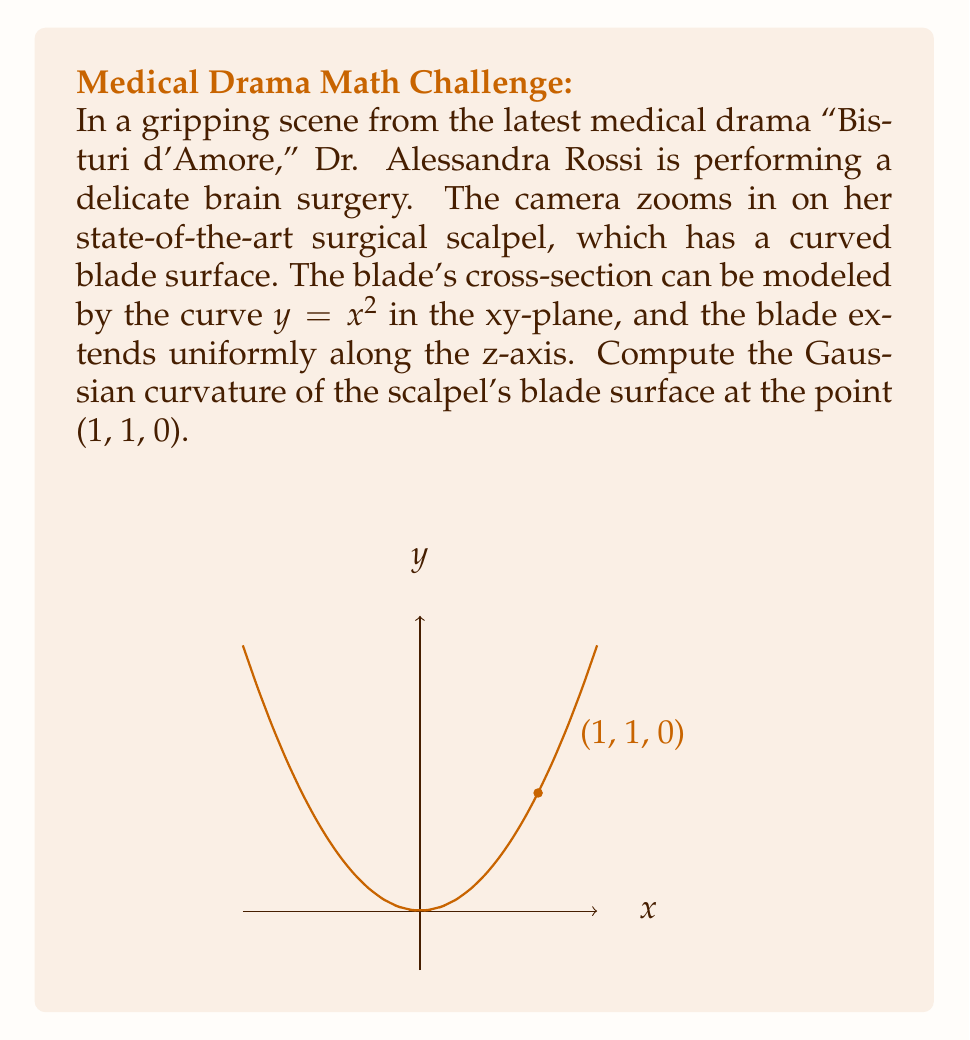Can you answer this question? To compute the Gaussian curvature of the scalpel's blade surface, we'll follow these steps:

1) The surface is a cylinder with the directrix $y = x^2$ and generatrix parallel to the z-axis. This is a ruled surface.

2) For a ruled surface where one of the principal directions is along the rulings (z-axis in this case), the Gaussian curvature K is given by:

   $$K = -\frac{(k_n')^2}{(1 + k_n^2)^2}$$

   where $k_n$ is the normal curvature of the directrix curve.

3) To find $k_n$, we need to calculate the curvature of the curve $y = x^2$ at x = 1.

4) The curvature of a plane curve $y = f(x)$ is given by:

   $$k = \frac{|f''(x)|}{(1 + (f'(x))^2)^{3/2}}$$

5) For $y = x^2$:
   $f'(x) = 2x$
   $f''(x) = 2$

6) At x = 1:
   $$k_n = \frac{|2|}{(1 + (2)^2)^{3/2}} = \frac{2}{5\sqrt{5}}$$

7) Now, we need to find $k_n'$. Since $k_n$ is constant for this curve, $k_n' = 0$.

8) Substituting into the Gaussian curvature formula:

   $$K = -\frac{(0)^2}{(1 + (\frac{2}{5\sqrt{5}})^2)^2} = 0$$

Therefore, the Gaussian curvature of the scalpel's blade surface at (1, 1, 0) is 0.
Answer: 0 